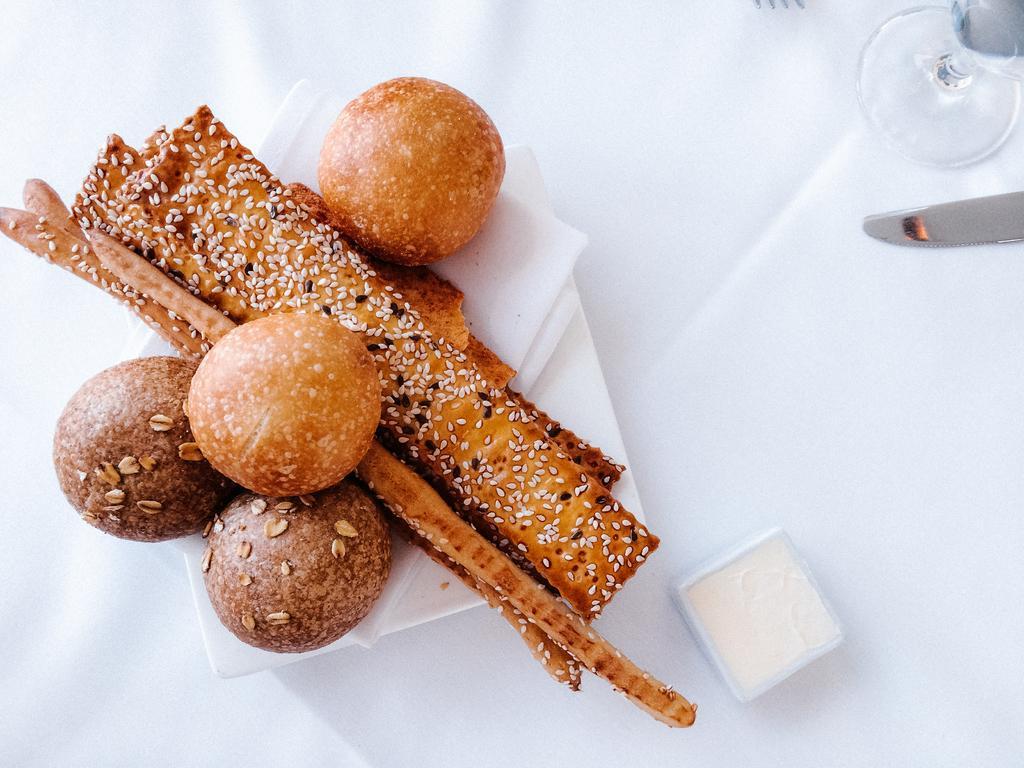How would you summarize this image in a sentence or two? In this image, I can see a knife, glass, an object and food items in a plate, which are on the white surface. 